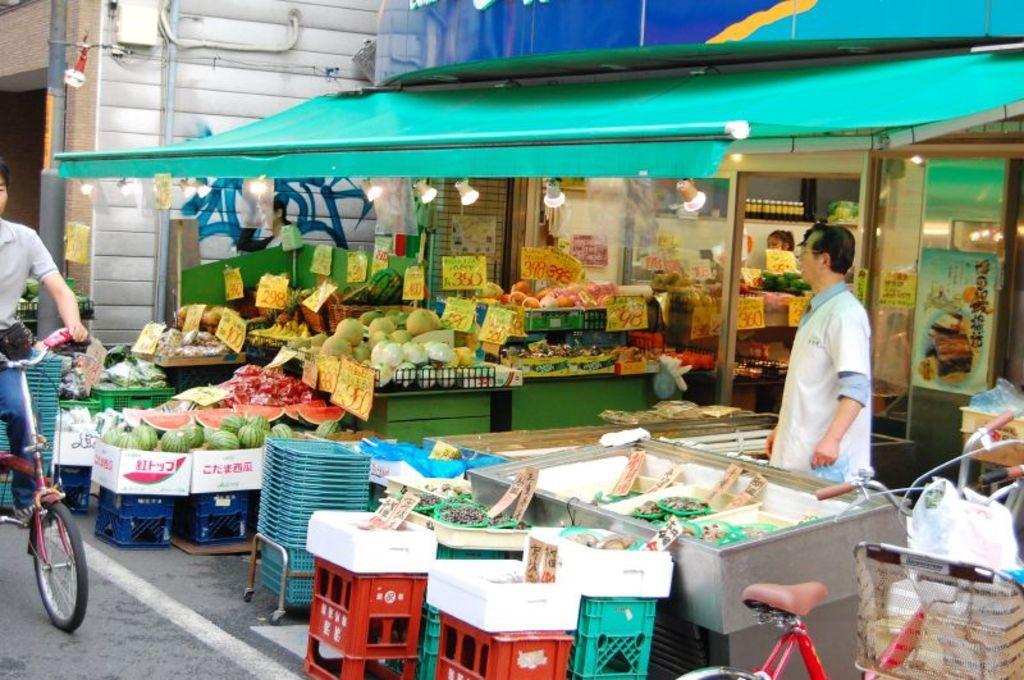Describe this image in one or two sentences. This image is taken outdoors. In the background there is a building. There are a few pipelines. On the left side of the image a man is riding on the bicycle and there are a few things on the road. In the middle of the image there is a tent and there is a store. There are many things in the store and there is a board with a text on it. A man is standing on the floor. There are many tables with many baskets, vegetables and fruits on them. There are a few cardboard boxes and there are many boards with text on them. There are a few lights. On the right side of the image there is a bicycle. 